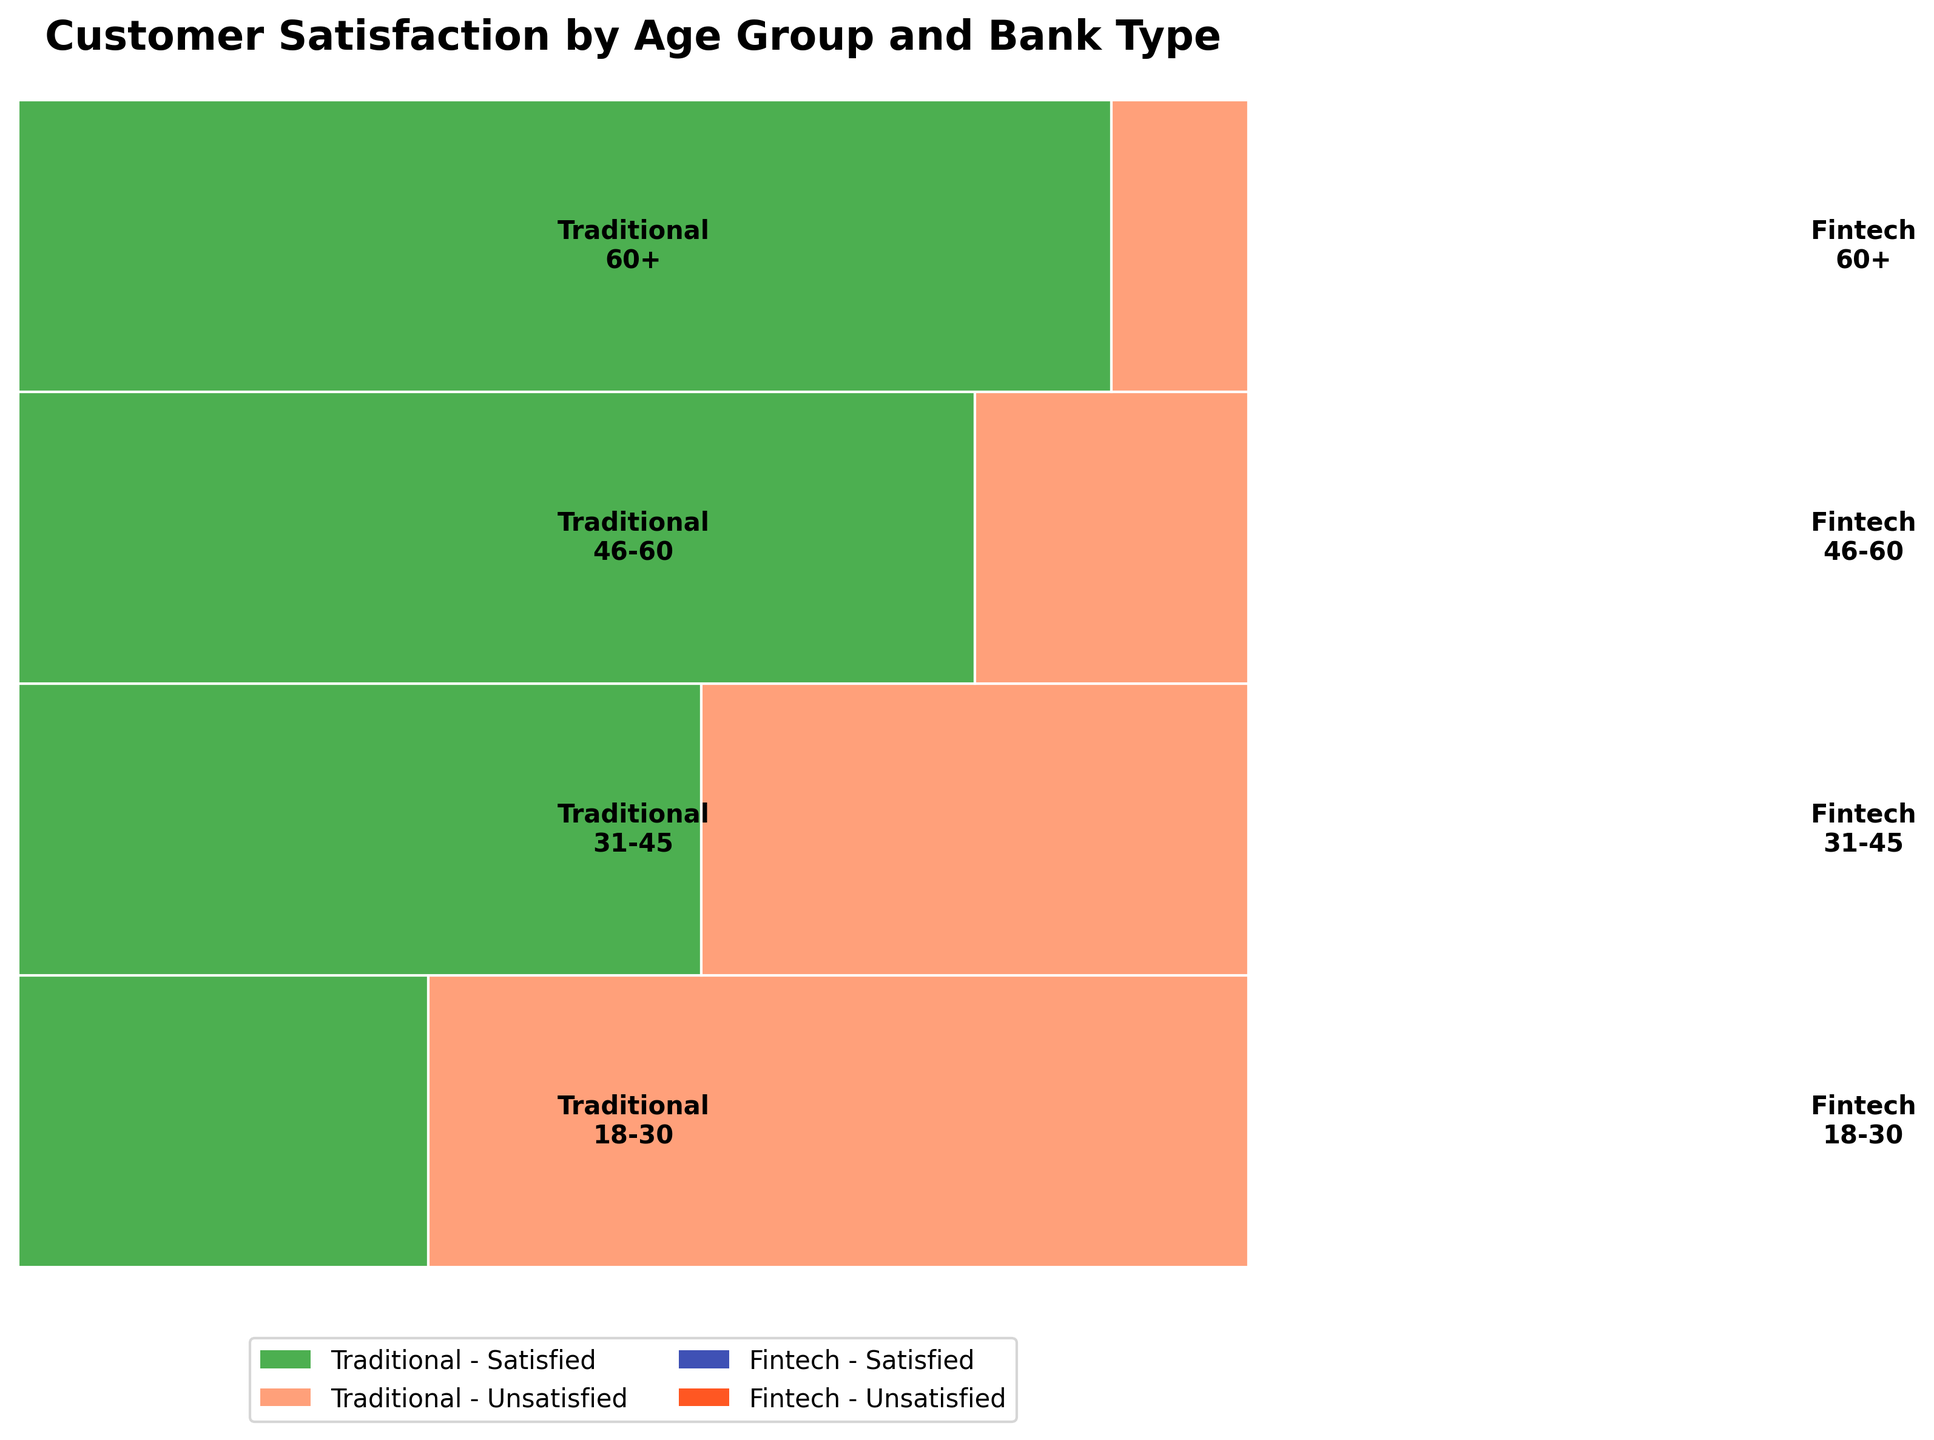What is the title of the mosaic plot? The title can be found at the top of the plot.
Answer: Customer Satisfaction by Age Group and Bank Type Which age group has the highest proportion of satisfied traditional bank customers? In the plot, look for the age group with the widest green rectangle representing satisfied traditional bank customers.
Answer: 60+ In the 31-45 age group, is the proportion of satisfied customers higher in traditional banks or fintech companies? Compare the width of the satisfaction rectangles in the 31-45 age group for both bank types.
Answer: Fintech companies How many age groups have a higher proportion of satisfied customers in fintech companies compared to traditional banks? Evaluate each age group separately and count where the blue satisfied fintech section is wider than the green satisfied traditional section.
Answer: 2 Which group has the lowest proportion of satisfied customers in fintech companies? Look for the age group with the smallest blue satisfied fintech rectangle.
Answer: 60+ What is the main difference in customer satisfaction for the 46-60 age group between traditional banks and fintech companies? Compare the widths of satisfaction and dissatisfaction sections for both bank types within the 46-60 age group.
Answer: Traditional banks have a much higher proportion of satisfied customers How do the satisfaction levels in the 18-30 age group compare between traditional banks and fintech companies? Compare the widths of satisfied and unsatisfied sections within the 18-30 age group for both bank types.
Answer: Fintech has more satisfied, but traditional has more unsatisfied In the 60+ age group, is there a higher proportion of unsatisfied customers in traditional banks or fintech companies? Compare the unsatisfied sections for both bank types in the 60+ age group.
Answer: Fintech companies Is there any age group where the proportion of unsatisfied fintech customers is higher than the proportion of satisfied fintech customers? Check if any age group has a wider red unsatisfied fintech section than the blue satisfied fintech section.
Answer: 60+ Overall, does the satisfaction level appear to be higher in traditional banks or fintech companies for customers aged 18-30? Sum the proportions of satisfied and unsatisfied sections for both bank types within the 18-30 age group.
Answer: Fintech companies 